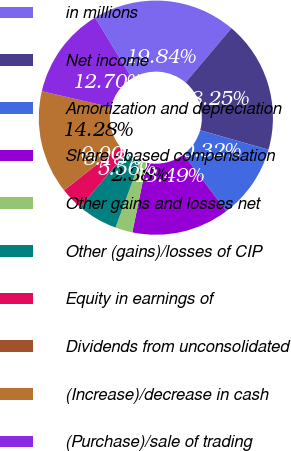Convert chart to OTSL. <chart><loc_0><loc_0><loc_500><loc_500><pie_chart><fcel>in millions<fcel>Net income<fcel>Amortization and depreciation<fcel>Share - based compensation<fcel>Other gains and losses net<fcel>Other (gains)/losses of CIP<fcel>Equity in earnings of<fcel>Dividends from unconsolidated<fcel>(Increase)/decrease in cash<fcel>(Purchase)/sale of trading<nl><fcel>19.84%<fcel>18.25%<fcel>10.32%<fcel>13.49%<fcel>2.38%<fcel>5.56%<fcel>3.18%<fcel>0.0%<fcel>14.28%<fcel>12.7%<nl></chart> 